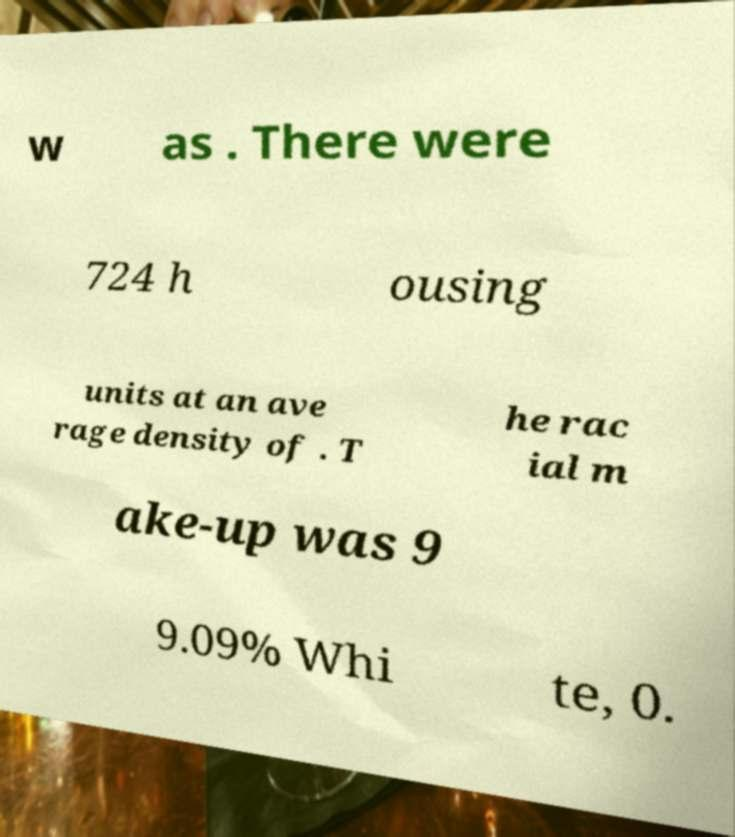I need the written content from this picture converted into text. Can you do that? w as . There were 724 h ousing units at an ave rage density of . T he rac ial m ake-up was 9 9.09% Whi te, 0. 